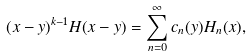<formula> <loc_0><loc_0><loc_500><loc_500>( x - y ) ^ { k - 1 } H ( x - y ) = \sum _ { n = 0 } ^ { \infty } c _ { n } ( y ) H _ { n } ( x ) ,</formula> 